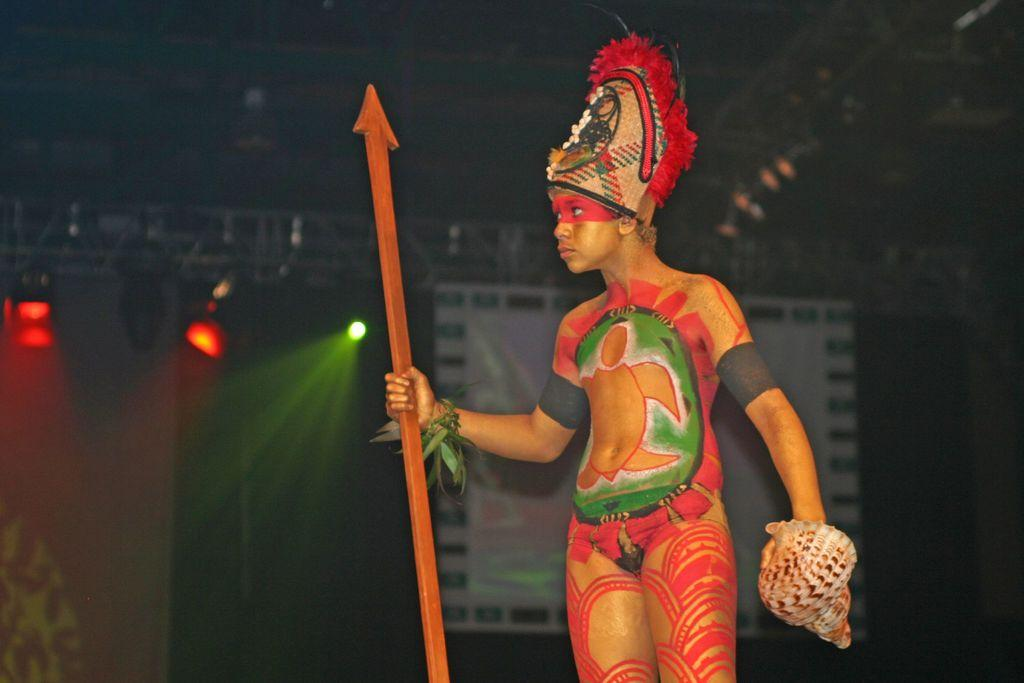What is the main subject in the foreground of the image? There is a boy in the foreground of the image. What is the boy holding in his hand? The boy is holding a stick and an unspecified instrument. What type of umbrella is the boy using to protect himself from the chickens in the image? There is no umbrella or chickens present in the image. 